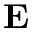Convert formula to latex. <formula><loc_0><loc_0><loc_500><loc_500>{ \delta E }</formula> 